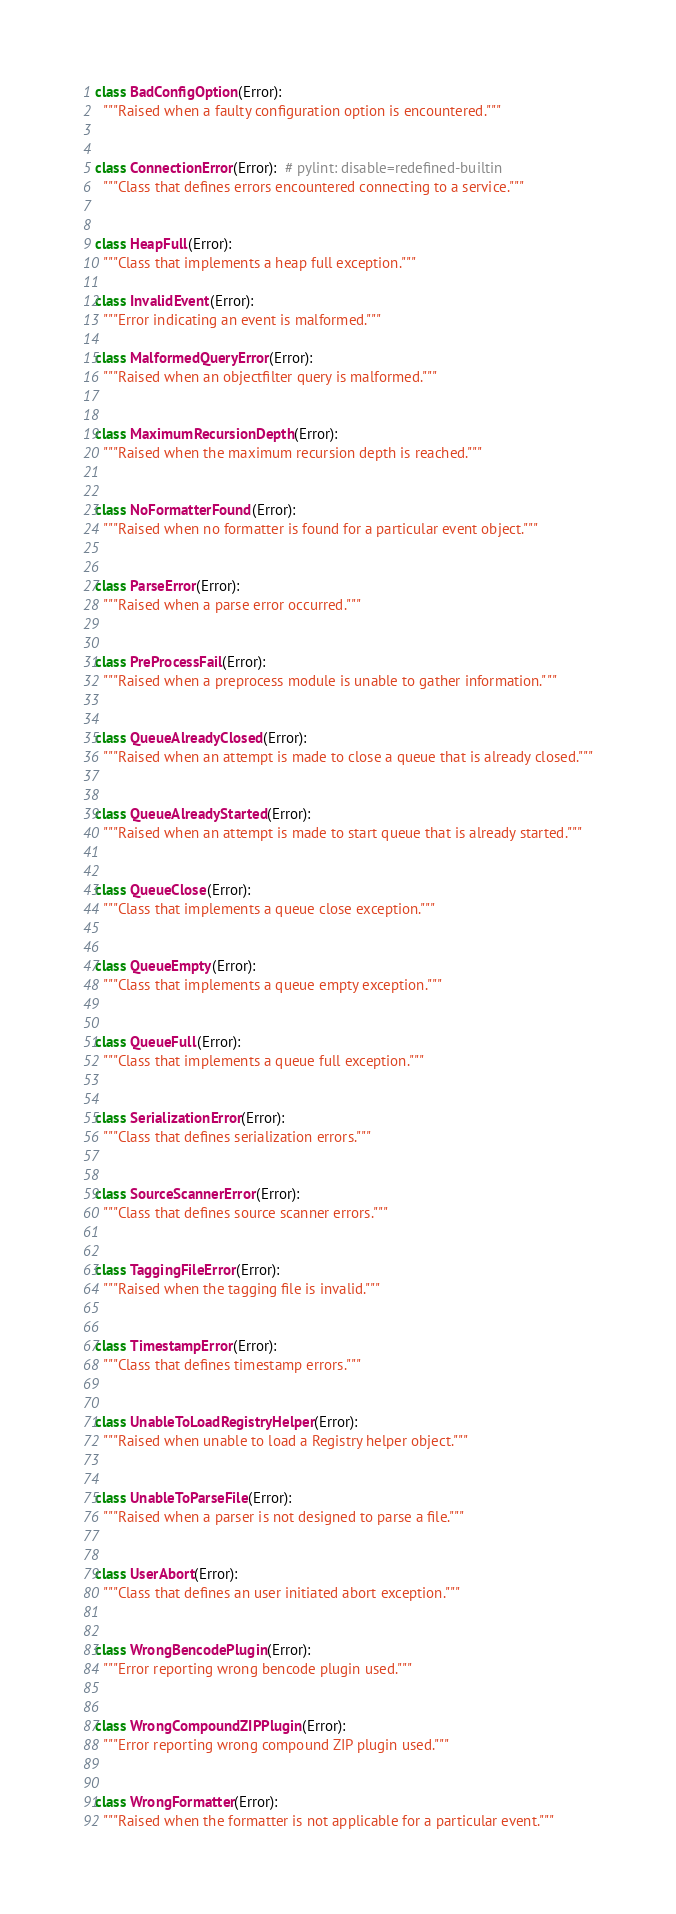Convert code to text. <code><loc_0><loc_0><loc_500><loc_500><_Python_>

class BadConfigOption(Error):
  """Raised when a faulty configuration option is encountered."""


class ConnectionError(Error):  # pylint: disable=redefined-builtin
  """Class that defines errors encountered connecting to a service."""


class HeapFull(Error):
  """Class that implements a heap full exception."""

class InvalidEvent(Error):
  """Error indicating an event is malformed."""

class MalformedQueryError(Error):
  """Raised when an objectfilter query is malformed."""


class MaximumRecursionDepth(Error):
  """Raised when the maximum recursion depth is reached."""


class NoFormatterFound(Error):
  """Raised when no formatter is found for a particular event object."""


class ParseError(Error):
  """Raised when a parse error occurred."""


class PreProcessFail(Error):
  """Raised when a preprocess module is unable to gather information."""


class QueueAlreadyClosed(Error):
  """Raised when an attempt is made to close a queue that is already closed."""


class QueueAlreadyStarted(Error):
  """Raised when an attempt is made to start queue that is already started."""


class QueueClose(Error):
  """Class that implements a queue close exception."""


class QueueEmpty(Error):
  """Class that implements a queue empty exception."""


class QueueFull(Error):
  """Class that implements a queue full exception."""


class SerializationError(Error):
  """Class that defines serialization errors."""


class SourceScannerError(Error):
  """Class that defines source scanner errors."""


class TaggingFileError(Error):
  """Raised when the tagging file is invalid."""


class TimestampError(Error):
  """Class that defines timestamp errors."""


class UnableToLoadRegistryHelper(Error):
  """Raised when unable to load a Registry helper object."""


class UnableToParseFile(Error):
  """Raised when a parser is not designed to parse a file."""


class UserAbort(Error):
  """Class that defines an user initiated abort exception."""


class WrongBencodePlugin(Error):
  """Error reporting wrong bencode plugin used."""


class WrongCompoundZIPPlugin(Error):
  """Error reporting wrong compound ZIP plugin used."""


class WrongFormatter(Error):
  """Raised when the formatter is not applicable for a particular event."""

</code> 